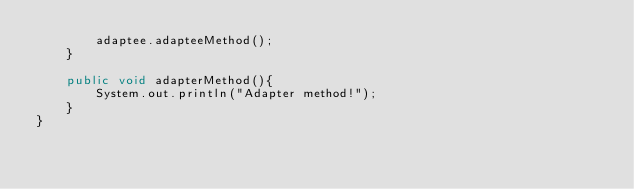<code> <loc_0><loc_0><loc_500><loc_500><_Java_>		adaptee.adapteeMethod();
	}

	public void adapterMethod(){
		System.out.println("Adapter method!");
	}
}

</code> 